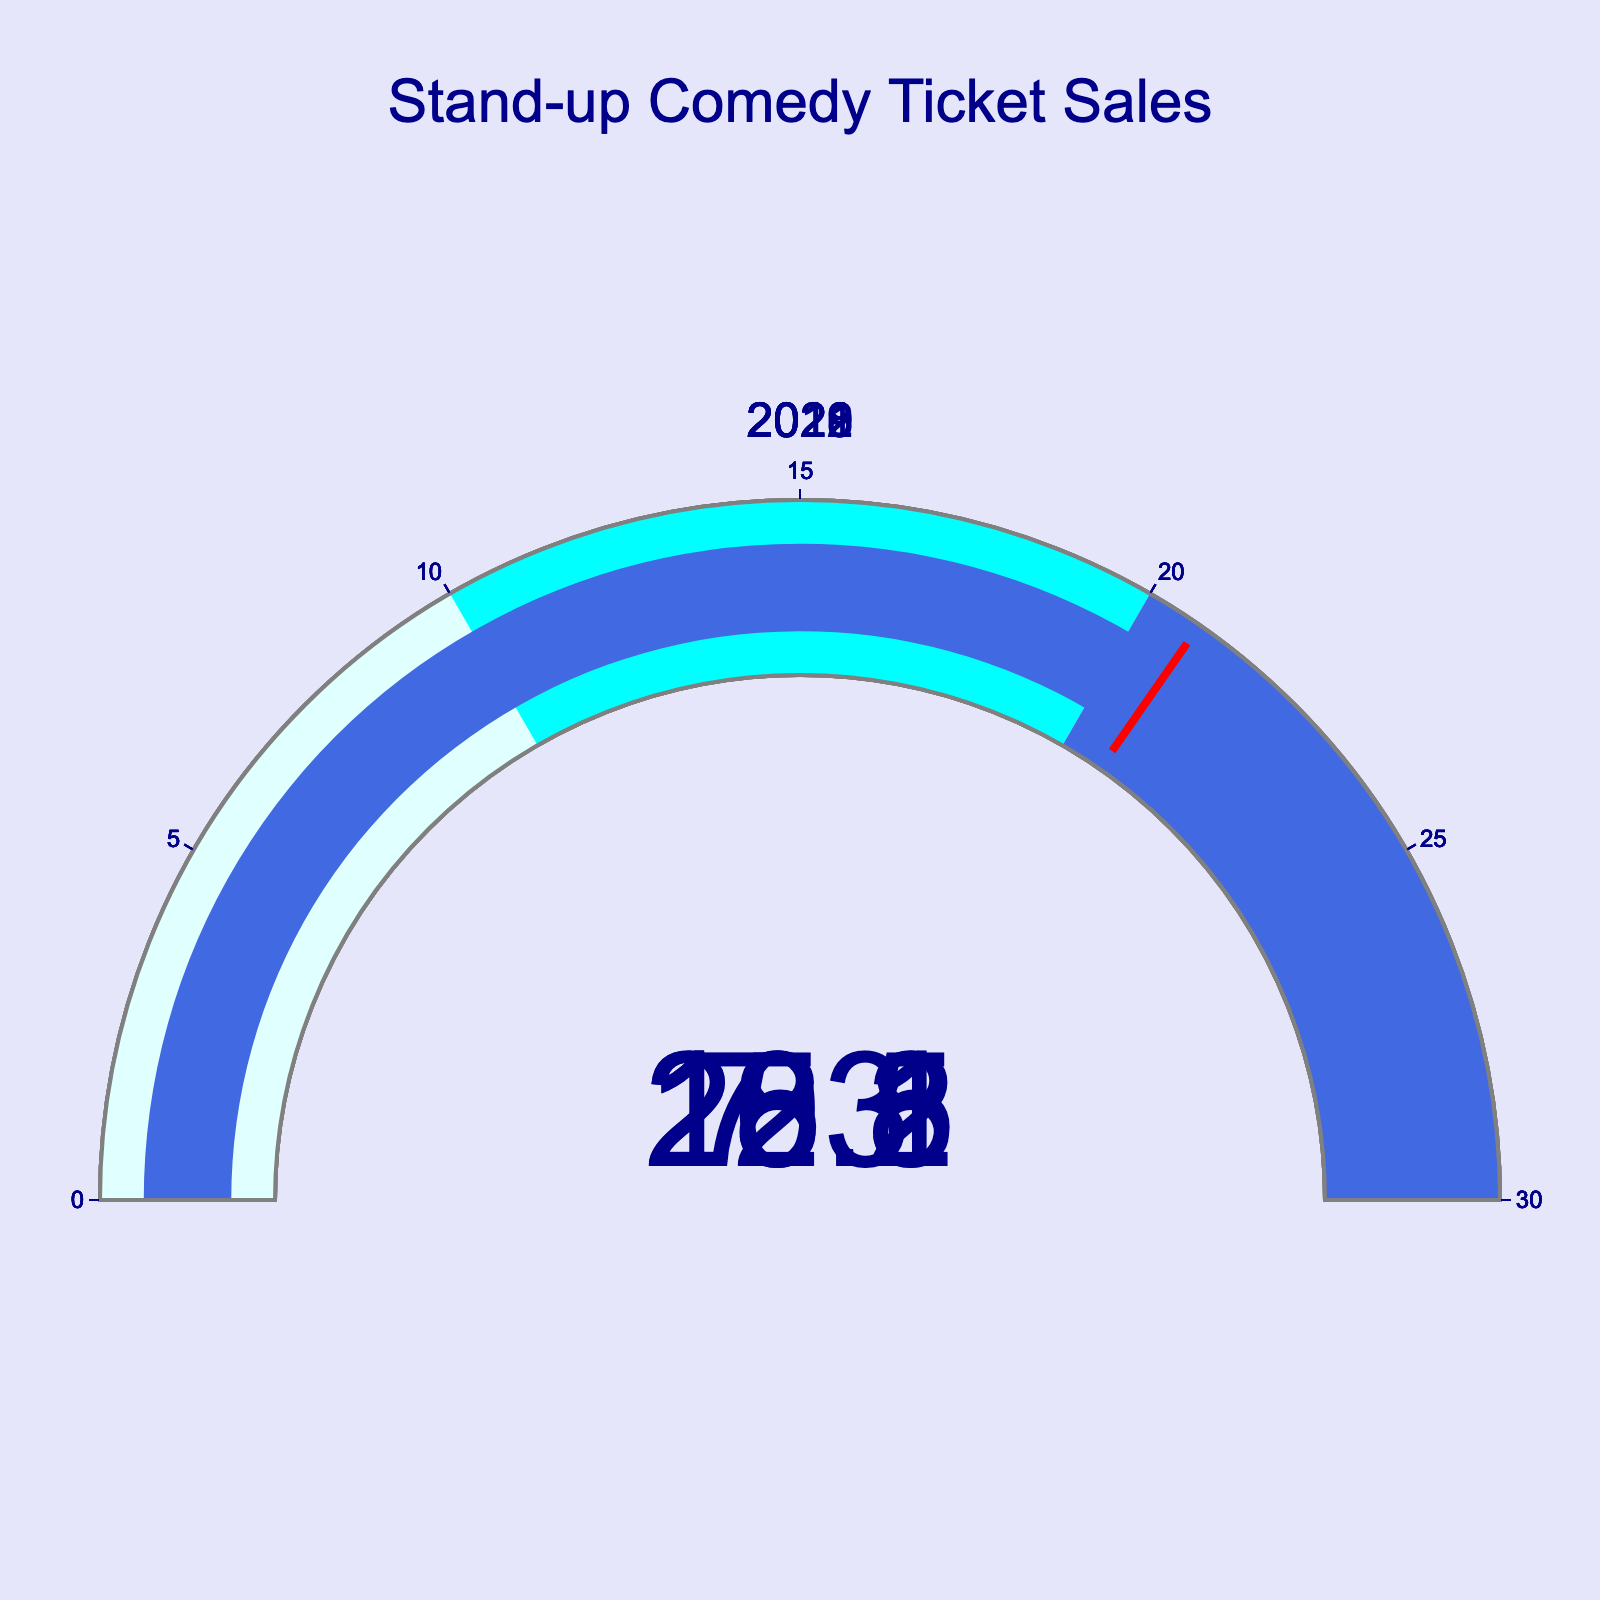Which year had the highest percentage of ticket sales for stand-up comedy shows? By looking at the gauge charts, find the one with the highest value. The chart for 2019 has the highest percentage at 22.1%.
Answer: 2019 What is the percentage difference in ticket sales between 2021 and 2020? Subtract the percentage of 2020 from that of 2021: 15.2% - 7.3% = 7.9%.
Answer: 7.9% Considering all the displayed years, what is the average percentage of ticket sales for stand-up comedy shows? Sum all the percentages and divide by the number of years: (18.5 + 15.2 + 7.3 + 22.1 + 20.8) / 5 = 16.78%.
Answer: 16.78% Which year had the lowest percentage of ticket sales for stand-up comedy shows? By looking at the gauge charts, find the one with the lowest value. The chart for 2020 has the lowest percentage at 7.3%.
Answer: 2020 How many years have their ticket sales percentages above 15%? Count the years where the percentage is greater than 15%. Years 2022, 2021, 2019, and 2018 have values above 15%. The count is 4.
Answer: 4 What is the median percentage of ticket sales for the given years? Organize the percentages in ascending order (7.3, 15.2, 18.5, 20.8, 22.1) and find the middle value, which is 18.5%.
Answer: 18.5% 